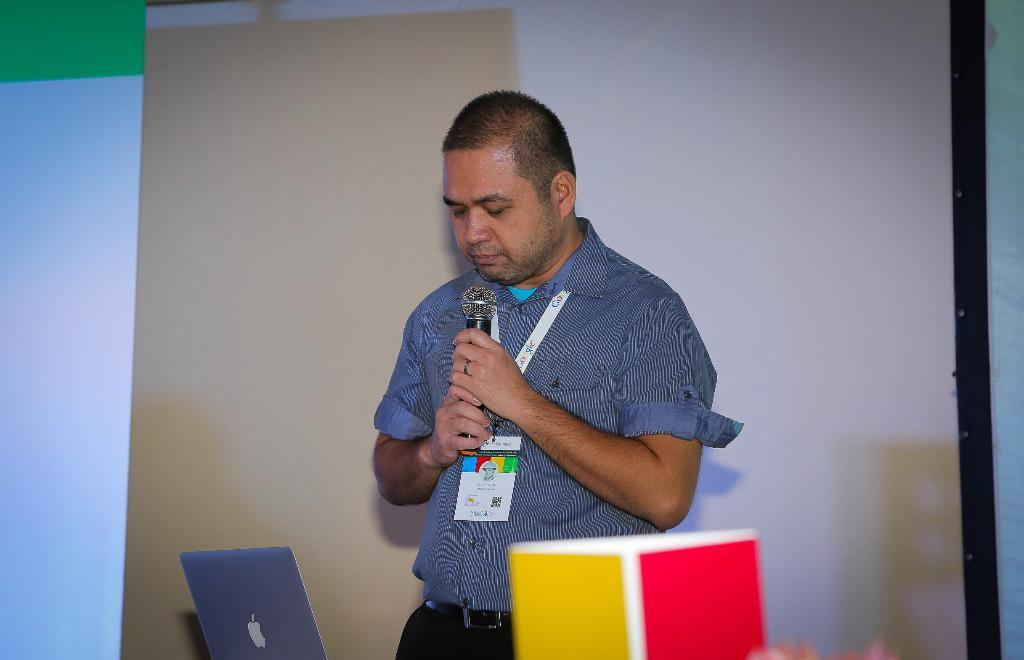What is the man in the image doing? The man is standing in the image and holding a microphone in his hand. What object is visible near the man? There is a laptop visible in the image. Can you describe the man's attire? The man is wearing an ID card. What can be seen in the background of the image? There is a screen visible in the background of the image. How does the man make the van sound in the image? There is no van present in the image, and the man is not making any van sounds. 